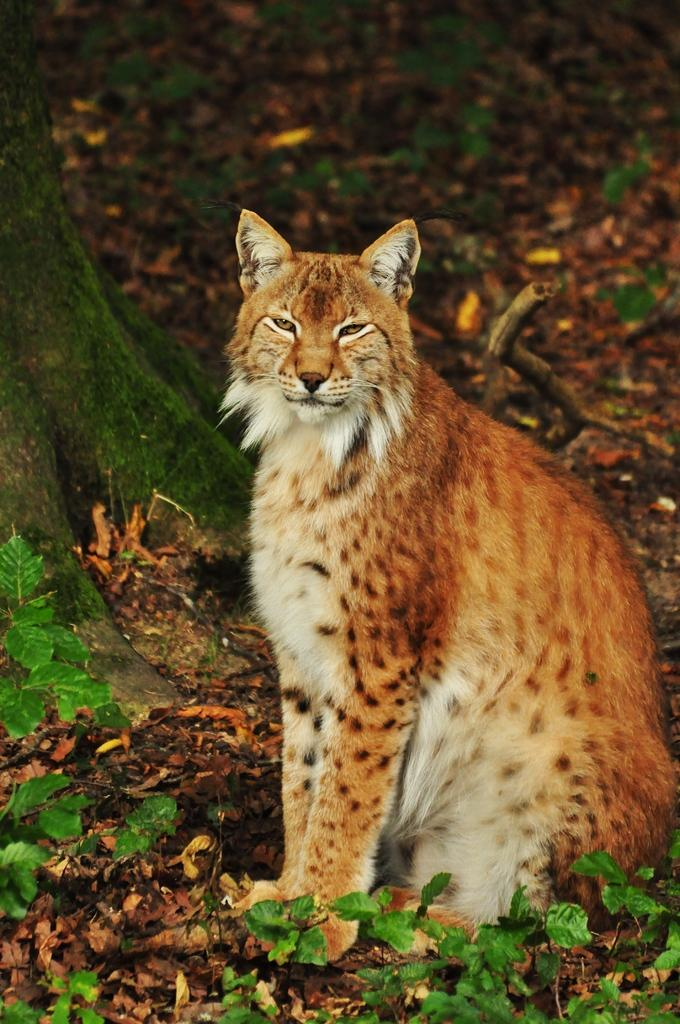What type of animal is in the image? There is a bobcat in the image. What can be seen on the left side of the image? There is a tree on the left side of the image. What is present at the bottom of the image? Leaves are present at the bottom of the image. What type of fruit is hanging from the tree in the image? There is no fruit visible in the image; only a bobcat and a tree are present. 